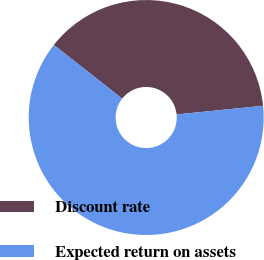Convert chart. <chart><loc_0><loc_0><loc_500><loc_500><pie_chart><fcel>Discount rate<fcel>Expected return on assets<nl><fcel>37.81%<fcel>62.19%<nl></chart> 